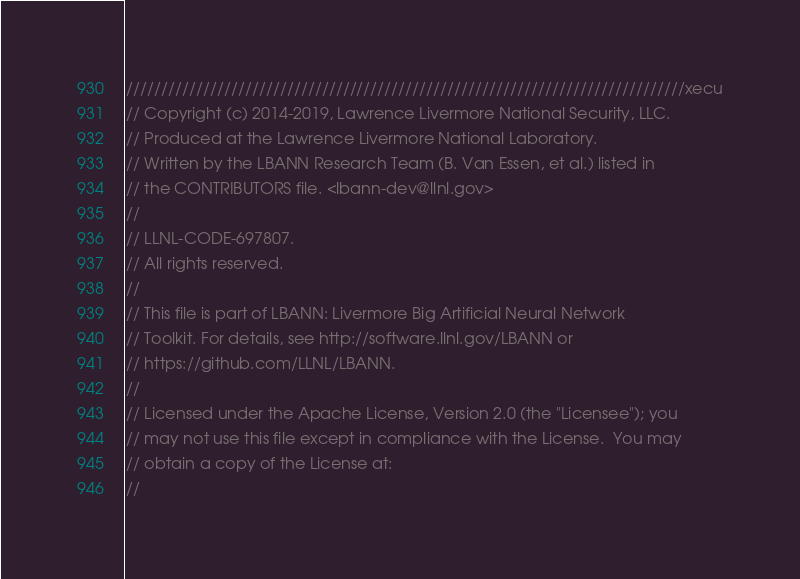Convert code to text. <code><loc_0><loc_0><loc_500><loc_500><_C++_>////////////////////////////////////////////////////////////////////////////////xecu
// Copyright (c) 2014-2019, Lawrence Livermore National Security, LLC.
// Produced at the Lawrence Livermore National Laboratory.
// Written by the LBANN Research Team (B. Van Essen, et al.) listed in
// the CONTRIBUTORS file. <lbann-dev@llnl.gov>
//
// LLNL-CODE-697807.
// All rights reserved.
//
// This file is part of LBANN: Livermore Big Artificial Neural Network
// Toolkit. For details, see http://software.llnl.gov/LBANN or
// https://github.com/LLNL/LBANN.
//
// Licensed under the Apache License, Version 2.0 (the "Licensee"); you
// may not use this file except in compliance with the License.  You may
// obtain a copy of the License at:
//</code> 